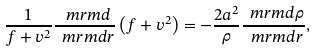<formula> <loc_0><loc_0><loc_500><loc_500>\frac { 1 } { f + v ^ { 2 } } \frac { \ m r m { d } } { { \ m r m d } r } \left ( f + v ^ { 2 } \right ) = - \frac { 2 a ^ { 2 } } { \rho } \frac { { \ m r m d } \rho } { { \ m r m d } r } ,</formula> 